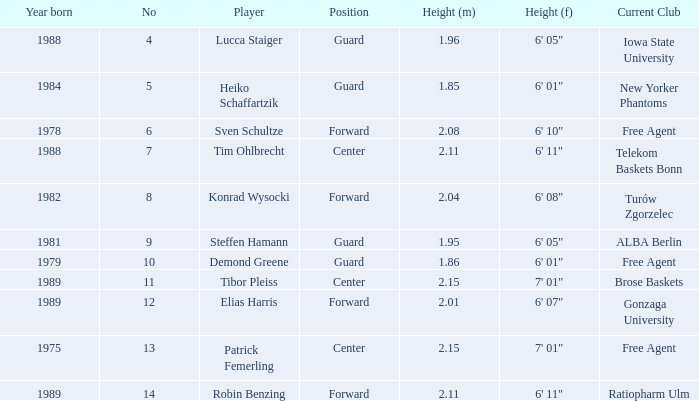Name the player that is 1.85 m Heiko Schaffartzik. 